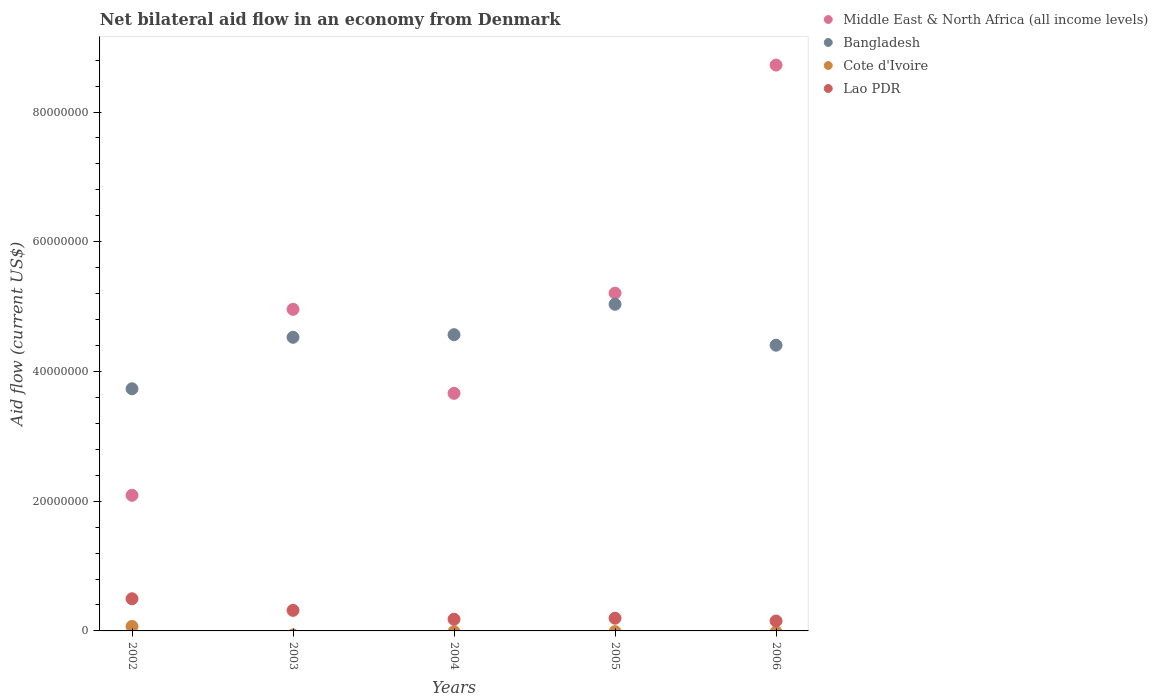How many different coloured dotlines are there?
Give a very brief answer. 4. Is the number of dotlines equal to the number of legend labels?
Offer a very short reply. No. What is the net bilateral aid flow in Middle East & North Africa (all income levels) in 2004?
Your answer should be compact. 3.66e+07. Across all years, what is the maximum net bilateral aid flow in Lao PDR?
Provide a succinct answer. 4.96e+06. Across all years, what is the minimum net bilateral aid flow in Cote d'Ivoire?
Ensure brevity in your answer.  0. In which year was the net bilateral aid flow in Cote d'Ivoire maximum?
Ensure brevity in your answer.  2002. What is the total net bilateral aid flow in Middle East & North Africa (all income levels) in the graph?
Offer a very short reply. 2.46e+08. What is the difference between the net bilateral aid flow in Bangladesh in 2003 and that in 2006?
Keep it short and to the point. 1.22e+06. What is the difference between the net bilateral aid flow in Middle East & North Africa (all income levels) in 2002 and the net bilateral aid flow in Cote d'Ivoire in 2003?
Your answer should be very brief. 2.09e+07. What is the average net bilateral aid flow in Bangladesh per year?
Give a very brief answer. 4.45e+07. In the year 2004, what is the difference between the net bilateral aid flow in Lao PDR and net bilateral aid flow in Middle East & North Africa (all income levels)?
Your response must be concise. -3.48e+07. In how many years, is the net bilateral aid flow in Middle East & North Africa (all income levels) greater than 24000000 US$?
Give a very brief answer. 4. What is the ratio of the net bilateral aid flow in Lao PDR in 2004 to that in 2006?
Give a very brief answer. 1.18. What is the difference between the highest and the second highest net bilateral aid flow in Lao PDR?
Offer a terse response. 1.79e+06. What is the difference between the highest and the lowest net bilateral aid flow in Middle East & North Africa (all income levels)?
Make the answer very short. 6.63e+07. In how many years, is the net bilateral aid flow in Bangladesh greater than the average net bilateral aid flow in Bangladesh taken over all years?
Your answer should be very brief. 3. Is the sum of the net bilateral aid flow in Middle East & North Africa (all income levels) in 2002 and 2004 greater than the maximum net bilateral aid flow in Bangladesh across all years?
Ensure brevity in your answer.  Yes. Is it the case that in every year, the sum of the net bilateral aid flow in Cote d'Ivoire and net bilateral aid flow in Lao PDR  is greater than the net bilateral aid flow in Middle East & North Africa (all income levels)?
Your answer should be compact. No. Is the net bilateral aid flow in Lao PDR strictly greater than the net bilateral aid flow in Middle East & North Africa (all income levels) over the years?
Make the answer very short. No. How many years are there in the graph?
Your response must be concise. 5. Does the graph contain grids?
Your response must be concise. No. How are the legend labels stacked?
Your response must be concise. Vertical. What is the title of the graph?
Provide a succinct answer. Net bilateral aid flow in an economy from Denmark. Does "Mozambique" appear as one of the legend labels in the graph?
Make the answer very short. No. What is the label or title of the Y-axis?
Keep it short and to the point. Aid flow (current US$). What is the Aid flow (current US$) of Middle East & North Africa (all income levels) in 2002?
Ensure brevity in your answer.  2.09e+07. What is the Aid flow (current US$) in Bangladesh in 2002?
Offer a very short reply. 3.73e+07. What is the Aid flow (current US$) of Cote d'Ivoire in 2002?
Give a very brief answer. 6.90e+05. What is the Aid flow (current US$) of Lao PDR in 2002?
Provide a short and direct response. 4.96e+06. What is the Aid flow (current US$) in Middle East & North Africa (all income levels) in 2003?
Your answer should be very brief. 4.96e+07. What is the Aid flow (current US$) in Bangladesh in 2003?
Offer a very short reply. 4.53e+07. What is the Aid flow (current US$) of Cote d'Ivoire in 2003?
Make the answer very short. 0. What is the Aid flow (current US$) of Lao PDR in 2003?
Your answer should be very brief. 3.17e+06. What is the Aid flow (current US$) of Middle East & North Africa (all income levels) in 2004?
Offer a very short reply. 3.66e+07. What is the Aid flow (current US$) of Bangladesh in 2004?
Your response must be concise. 4.57e+07. What is the Aid flow (current US$) in Lao PDR in 2004?
Provide a short and direct response. 1.80e+06. What is the Aid flow (current US$) in Middle East & North Africa (all income levels) in 2005?
Make the answer very short. 5.21e+07. What is the Aid flow (current US$) in Bangladesh in 2005?
Provide a short and direct response. 5.04e+07. What is the Aid flow (current US$) in Cote d'Ivoire in 2005?
Ensure brevity in your answer.  0. What is the Aid flow (current US$) of Lao PDR in 2005?
Offer a very short reply. 1.96e+06. What is the Aid flow (current US$) in Middle East & North Africa (all income levels) in 2006?
Give a very brief answer. 8.72e+07. What is the Aid flow (current US$) in Bangladesh in 2006?
Provide a succinct answer. 4.40e+07. What is the Aid flow (current US$) in Lao PDR in 2006?
Your answer should be compact. 1.53e+06. Across all years, what is the maximum Aid flow (current US$) of Middle East & North Africa (all income levels)?
Provide a short and direct response. 8.72e+07. Across all years, what is the maximum Aid flow (current US$) of Bangladesh?
Your response must be concise. 5.04e+07. Across all years, what is the maximum Aid flow (current US$) in Cote d'Ivoire?
Offer a terse response. 6.90e+05. Across all years, what is the maximum Aid flow (current US$) in Lao PDR?
Your response must be concise. 4.96e+06. Across all years, what is the minimum Aid flow (current US$) in Middle East & North Africa (all income levels)?
Provide a short and direct response. 2.09e+07. Across all years, what is the minimum Aid flow (current US$) in Bangladesh?
Ensure brevity in your answer.  3.73e+07. Across all years, what is the minimum Aid flow (current US$) of Lao PDR?
Ensure brevity in your answer.  1.53e+06. What is the total Aid flow (current US$) in Middle East & North Africa (all income levels) in the graph?
Ensure brevity in your answer.  2.46e+08. What is the total Aid flow (current US$) in Bangladesh in the graph?
Your answer should be compact. 2.23e+08. What is the total Aid flow (current US$) of Cote d'Ivoire in the graph?
Provide a short and direct response. 6.90e+05. What is the total Aid flow (current US$) of Lao PDR in the graph?
Your answer should be very brief. 1.34e+07. What is the difference between the Aid flow (current US$) in Middle East & North Africa (all income levels) in 2002 and that in 2003?
Offer a very short reply. -2.87e+07. What is the difference between the Aid flow (current US$) of Bangladesh in 2002 and that in 2003?
Give a very brief answer. -7.94e+06. What is the difference between the Aid flow (current US$) of Lao PDR in 2002 and that in 2003?
Your response must be concise. 1.79e+06. What is the difference between the Aid flow (current US$) of Middle East & North Africa (all income levels) in 2002 and that in 2004?
Ensure brevity in your answer.  -1.57e+07. What is the difference between the Aid flow (current US$) of Bangladesh in 2002 and that in 2004?
Give a very brief answer. -8.34e+06. What is the difference between the Aid flow (current US$) of Lao PDR in 2002 and that in 2004?
Your answer should be compact. 3.16e+06. What is the difference between the Aid flow (current US$) of Middle East & North Africa (all income levels) in 2002 and that in 2005?
Your answer should be very brief. -3.12e+07. What is the difference between the Aid flow (current US$) of Bangladesh in 2002 and that in 2005?
Give a very brief answer. -1.30e+07. What is the difference between the Aid flow (current US$) in Lao PDR in 2002 and that in 2005?
Keep it short and to the point. 3.00e+06. What is the difference between the Aid flow (current US$) of Middle East & North Africa (all income levels) in 2002 and that in 2006?
Ensure brevity in your answer.  -6.63e+07. What is the difference between the Aid flow (current US$) in Bangladesh in 2002 and that in 2006?
Provide a short and direct response. -6.72e+06. What is the difference between the Aid flow (current US$) of Lao PDR in 2002 and that in 2006?
Your answer should be compact. 3.43e+06. What is the difference between the Aid flow (current US$) of Middle East & North Africa (all income levels) in 2003 and that in 2004?
Provide a short and direct response. 1.30e+07. What is the difference between the Aid flow (current US$) of Bangladesh in 2003 and that in 2004?
Your response must be concise. -4.00e+05. What is the difference between the Aid flow (current US$) in Lao PDR in 2003 and that in 2004?
Ensure brevity in your answer.  1.37e+06. What is the difference between the Aid flow (current US$) in Middle East & North Africa (all income levels) in 2003 and that in 2005?
Give a very brief answer. -2.50e+06. What is the difference between the Aid flow (current US$) of Bangladesh in 2003 and that in 2005?
Ensure brevity in your answer.  -5.09e+06. What is the difference between the Aid flow (current US$) in Lao PDR in 2003 and that in 2005?
Offer a terse response. 1.21e+06. What is the difference between the Aid flow (current US$) in Middle East & North Africa (all income levels) in 2003 and that in 2006?
Offer a very short reply. -3.77e+07. What is the difference between the Aid flow (current US$) in Bangladesh in 2003 and that in 2006?
Keep it short and to the point. 1.22e+06. What is the difference between the Aid flow (current US$) in Lao PDR in 2003 and that in 2006?
Ensure brevity in your answer.  1.64e+06. What is the difference between the Aid flow (current US$) in Middle East & North Africa (all income levels) in 2004 and that in 2005?
Provide a short and direct response. -1.54e+07. What is the difference between the Aid flow (current US$) in Bangladesh in 2004 and that in 2005?
Offer a very short reply. -4.69e+06. What is the difference between the Aid flow (current US$) of Lao PDR in 2004 and that in 2005?
Your response must be concise. -1.60e+05. What is the difference between the Aid flow (current US$) of Middle East & North Africa (all income levels) in 2004 and that in 2006?
Make the answer very short. -5.06e+07. What is the difference between the Aid flow (current US$) in Bangladesh in 2004 and that in 2006?
Offer a very short reply. 1.62e+06. What is the difference between the Aid flow (current US$) of Lao PDR in 2004 and that in 2006?
Ensure brevity in your answer.  2.70e+05. What is the difference between the Aid flow (current US$) in Middle East & North Africa (all income levels) in 2005 and that in 2006?
Provide a short and direct response. -3.52e+07. What is the difference between the Aid flow (current US$) of Bangladesh in 2005 and that in 2006?
Your answer should be compact. 6.31e+06. What is the difference between the Aid flow (current US$) of Middle East & North Africa (all income levels) in 2002 and the Aid flow (current US$) of Bangladesh in 2003?
Offer a very short reply. -2.44e+07. What is the difference between the Aid flow (current US$) in Middle East & North Africa (all income levels) in 2002 and the Aid flow (current US$) in Lao PDR in 2003?
Your response must be concise. 1.77e+07. What is the difference between the Aid flow (current US$) of Bangladesh in 2002 and the Aid flow (current US$) of Lao PDR in 2003?
Provide a succinct answer. 3.42e+07. What is the difference between the Aid flow (current US$) in Cote d'Ivoire in 2002 and the Aid flow (current US$) in Lao PDR in 2003?
Your answer should be very brief. -2.48e+06. What is the difference between the Aid flow (current US$) in Middle East & North Africa (all income levels) in 2002 and the Aid flow (current US$) in Bangladesh in 2004?
Your answer should be very brief. -2.48e+07. What is the difference between the Aid flow (current US$) in Middle East & North Africa (all income levels) in 2002 and the Aid flow (current US$) in Lao PDR in 2004?
Keep it short and to the point. 1.91e+07. What is the difference between the Aid flow (current US$) of Bangladesh in 2002 and the Aid flow (current US$) of Lao PDR in 2004?
Your response must be concise. 3.55e+07. What is the difference between the Aid flow (current US$) of Cote d'Ivoire in 2002 and the Aid flow (current US$) of Lao PDR in 2004?
Provide a short and direct response. -1.11e+06. What is the difference between the Aid flow (current US$) in Middle East & North Africa (all income levels) in 2002 and the Aid flow (current US$) in Bangladesh in 2005?
Ensure brevity in your answer.  -2.94e+07. What is the difference between the Aid flow (current US$) of Middle East & North Africa (all income levels) in 2002 and the Aid flow (current US$) of Lao PDR in 2005?
Give a very brief answer. 1.90e+07. What is the difference between the Aid flow (current US$) of Bangladesh in 2002 and the Aid flow (current US$) of Lao PDR in 2005?
Provide a succinct answer. 3.54e+07. What is the difference between the Aid flow (current US$) in Cote d'Ivoire in 2002 and the Aid flow (current US$) in Lao PDR in 2005?
Give a very brief answer. -1.27e+06. What is the difference between the Aid flow (current US$) of Middle East & North Africa (all income levels) in 2002 and the Aid flow (current US$) of Bangladesh in 2006?
Provide a succinct answer. -2.31e+07. What is the difference between the Aid flow (current US$) of Middle East & North Africa (all income levels) in 2002 and the Aid flow (current US$) of Lao PDR in 2006?
Your response must be concise. 1.94e+07. What is the difference between the Aid flow (current US$) of Bangladesh in 2002 and the Aid flow (current US$) of Lao PDR in 2006?
Your response must be concise. 3.58e+07. What is the difference between the Aid flow (current US$) in Cote d'Ivoire in 2002 and the Aid flow (current US$) in Lao PDR in 2006?
Offer a very short reply. -8.40e+05. What is the difference between the Aid flow (current US$) of Middle East & North Africa (all income levels) in 2003 and the Aid flow (current US$) of Bangladesh in 2004?
Your response must be concise. 3.91e+06. What is the difference between the Aid flow (current US$) of Middle East & North Africa (all income levels) in 2003 and the Aid flow (current US$) of Lao PDR in 2004?
Offer a terse response. 4.78e+07. What is the difference between the Aid flow (current US$) in Bangladesh in 2003 and the Aid flow (current US$) in Lao PDR in 2004?
Your answer should be compact. 4.35e+07. What is the difference between the Aid flow (current US$) in Middle East & North Africa (all income levels) in 2003 and the Aid flow (current US$) in Bangladesh in 2005?
Offer a very short reply. -7.80e+05. What is the difference between the Aid flow (current US$) of Middle East & North Africa (all income levels) in 2003 and the Aid flow (current US$) of Lao PDR in 2005?
Make the answer very short. 4.76e+07. What is the difference between the Aid flow (current US$) of Bangladesh in 2003 and the Aid flow (current US$) of Lao PDR in 2005?
Offer a terse response. 4.33e+07. What is the difference between the Aid flow (current US$) of Middle East & North Africa (all income levels) in 2003 and the Aid flow (current US$) of Bangladesh in 2006?
Provide a succinct answer. 5.53e+06. What is the difference between the Aid flow (current US$) of Middle East & North Africa (all income levels) in 2003 and the Aid flow (current US$) of Lao PDR in 2006?
Offer a terse response. 4.80e+07. What is the difference between the Aid flow (current US$) of Bangladesh in 2003 and the Aid flow (current US$) of Lao PDR in 2006?
Offer a terse response. 4.37e+07. What is the difference between the Aid flow (current US$) in Middle East & North Africa (all income levels) in 2004 and the Aid flow (current US$) in Bangladesh in 2005?
Offer a very short reply. -1.37e+07. What is the difference between the Aid flow (current US$) of Middle East & North Africa (all income levels) in 2004 and the Aid flow (current US$) of Lao PDR in 2005?
Your answer should be compact. 3.47e+07. What is the difference between the Aid flow (current US$) in Bangladesh in 2004 and the Aid flow (current US$) in Lao PDR in 2005?
Your answer should be very brief. 4.37e+07. What is the difference between the Aid flow (current US$) of Middle East & North Africa (all income levels) in 2004 and the Aid flow (current US$) of Bangladesh in 2006?
Offer a terse response. -7.42e+06. What is the difference between the Aid flow (current US$) in Middle East & North Africa (all income levels) in 2004 and the Aid flow (current US$) in Lao PDR in 2006?
Keep it short and to the point. 3.51e+07. What is the difference between the Aid flow (current US$) of Bangladesh in 2004 and the Aid flow (current US$) of Lao PDR in 2006?
Offer a very short reply. 4.41e+07. What is the difference between the Aid flow (current US$) in Middle East & North Africa (all income levels) in 2005 and the Aid flow (current US$) in Bangladesh in 2006?
Ensure brevity in your answer.  8.03e+06. What is the difference between the Aid flow (current US$) of Middle East & North Africa (all income levels) in 2005 and the Aid flow (current US$) of Lao PDR in 2006?
Offer a very short reply. 5.06e+07. What is the difference between the Aid flow (current US$) in Bangladesh in 2005 and the Aid flow (current US$) in Lao PDR in 2006?
Provide a short and direct response. 4.88e+07. What is the average Aid flow (current US$) of Middle East & North Africa (all income levels) per year?
Offer a terse response. 4.93e+07. What is the average Aid flow (current US$) of Bangladesh per year?
Your response must be concise. 4.45e+07. What is the average Aid flow (current US$) in Cote d'Ivoire per year?
Provide a succinct answer. 1.38e+05. What is the average Aid flow (current US$) in Lao PDR per year?
Your answer should be compact. 2.68e+06. In the year 2002, what is the difference between the Aid flow (current US$) of Middle East & North Africa (all income levels) and Aid flow (current US$) of Bangladesh?
Give a very brief answer. -1.64e+07. In the year 2002, what is the difference between the Aid flow (current US$) of Middle East & North Africa (all income levels) and Aid flow (current US$) of Cote d'Ivoire?
Make the answer very short. 2.02e+07. In the year 2002, what is the difference between the Aid flow (current US$) in Middle East & North Africa (all income levels) and Aid flow (current US$) in Lao PDR?
Your answer should be very brief. 1.60e+07. In the year 2002, what is the difference between the Aid flow (current US$) in Bangladesh and Aid flow (current US$) in Cote d'Ivoire?
Offer a terse response. 3.66e+07. In the year 2002, what is the difference between the Aid flow (current US$) in Bangladesh and Aid flow (current US$) in Lao PDR?
Provide a succinct answer. 3.24e+07. In the year 2002, what is the difference between the Aid flow (current US$) of Cote d'Ivoire and Aid flow (current US$) of Lao PDR?
Your answer should be very brief. -4.27e+06. In the year 2003, what is the difference between the Aid flow (current US$) in Middle East & North Africa (all income levels) and Aid flow (current US$) in Bangladesh?
Make the answer very short. 4.31e+06. In the year 2003, what is the difference between the Aid flow (current US$) of Middle East & North Africa (all income levels) and Aid flow (current US$) of Lao PDR?
Ensure brevity in your answer.  4.64e+07. In the year 2003, what is the difference between the Aid flow (current US$) in Bangladesh and Aid flow (current US$) in Lao PDR?
Your answer should be compact. 4.21e+07. In the year 2004, what is the difference between the Aid flow (current US$) in Middle East & North Africa (all income levels) and Aid flow (current US$) in Bangladesh?
Ensure brevity in your answer.  -9.04e+06. In the year 2004, what is the difference between the Aid flow (current US$) in Middle East & North Africa (all income levels) and Aid flow (current US$) in Lao PDR?
Your answer should be compact. 3.48e+07. In the year 2004, what is the difference between the Aid flow (current US$) in Bangladesh and Aid flow (current US$) in Lao PDR?
Offer a terse response. 4.39e+07. In the year 2005, what is the difference between the Aid flow (current US$) of Middle East & North Africa (all income levels) and Aid flow (current US$) of Bangladesh?
Your answer should be very brief. 1.72e+06. In the year 2005, what is the difference between the Aid flow (current US$) of Middle East & North Africa (all income levels) and Aid flow (current US$) of Lao PDR?
Offer a terse response. 5.01e+07. In the year 2005, what is the difference between the Aid flow (current US$) in Bangladesh and Aid flow (current US$) in Lao PDR?
Provide a short and direct response. 4.84e+07. In the year 2006, what is the difference between the Aid flow (current US$) of Middle East & North Africa (all income levels) and Aid flow (current US$) of Bangladesh?
Offer a terse response. 4.32e+07. In the year 2006, what is the difference between the Aid flow (current US$) of Middle East & North Africa (all income levels) and Aid flow (current US$) of Lao PDR?
Give a very brief answer. 8.57e+07. In the year 2006, what is the difference between the Aid flow (current US$) of Bangladesh and Aid flow (current US$) of Lao PDR?
Make the answer very short. 4.25e+07. What is the ratio of the Aid flow (current US$) of Middle East & North Africa (all income levels) in 2002 to that in 2003?
Give a very brief answer. 0.42. What is the ratio of the Aid flow (current US$) in Bangladesh in 2002 to that in 2003?
Your response must be concise. 0.82. What is the ratio of the Aid flow (current US$) of Lao PDR in 2002 to that in 2003?
Provide a succinct answer. 1.56. What is the ratio of the Aid flow (current US$) of Middle East & North Africa (all income levels) in 2002 to that in 2004?
Keep it short and to the point. 0.57. What is the ratio of the Aid flow (current US$) of Bangladesh in 2002 to that in 2004?
Offer a very short reply. 0.82. What is the ratio of the Aid flow (current US$) in Lao PDR in 2002 to that in 2004?
Offer a very short reply. 2.76. What is the ratio of the Aid flow (current US$) in Middle East & North Africa (all income levels) in 2002 to that in 2005?
Make the answer very short. 0.4. What is the ratio of the Aid flow (current US$) of Bangladesh in 2002 to that in 2005?
Your answer should be compact. 0.74. What is the ratio of the Aid flow (current US$) in Lao PDR in 2002 to that in 2005?
Offer a very short reply. 2.53. What is the ratio of the Aid flow (current US$) of Middle East & North Africa (all income levels) in 2002 to that in 2006?
Your response must be concise. 0.24. What is the ratio of the Aid flow (current US$) of Bangladesh in 2002 to that in 2006?
Your response must be concise. 0.85. What is the ratio of the Aid flow (current US$) of Lao PDR in 2002 to that in 2006?
Keep it short and to the point. 3.24. What is the ratio of the Aid flow (current US$) in Middle East & North Africa (all income levels) in 2003 to that in 2004?
Offer a very short reply. 1.35. What is the ratio of the Aid flow (current US$) in Lao PDR in 2003 to that in 2004?
Keep it short and to the point. 1.76. What is the ratio of the Aid flow (current US$) of Middle East & North Africa (all income levels) in 2003 to that in 2005?
Provide a succinct answer. 0.95. What is the ratio of the Aid flow (current US$) of Bangladesh in 2003 to that in 2005?
Ensure brevity in your answer.  0.9. What is the ratio of the Aid flow (current US$) of Lao PDR in 2003 to that in 2005?
Make the answer very short. 1.62. What is the ratio of the Aid flow (current US$) in Middle East & North Africa (all income levels) in 2003 to that in 2006?
Provide a short and direct response. 0.57. What is the ratio of the Aid flow (current US$) of Bangladesh in 2003 to that in 2006?
Give a very brief answer. 1.03. What is the ratio of the Aid flow (current US$) in Lao PDR in 2003 to that in 2006?
Provide a short and direct response. 2.07. What is the ratio of the Aid flow (current US$) in Middle East & North Africa (all income levels) in 2004 to that in 2005?
Make the answer very short. 0.7. What is the ratio of the Aid flow (current US$) of Bangladesh in 2004 to that in 2005?
Offer a terse response. 0.91. What is the ratio of the Aid flow (current US$) of Lao PDR in 2004 to that in 2005?
Make the answer very short. 0.92. What is the ratio of the Aid flow (current US$) of Middle East & North Africa (all income levels) in 2004 to that in 2006?
Make the answer very short. 0.42. What is the ratio of the Aid flow (current US$) of Bangladesh in 2004 to that in 2006?
Your response must be concise. 1.04. What is the ratio of the Aid flow (current US$) of Lao PDR in 2004 to that in 2006?
Your response must be concise. 1.18. What is the ratio of the Aid flow (current US$) in Middle East & North Africa (all income levels) in 2005 to that in 2006?
Offer a terse response. 0.6. What is the ratio of the Aid flow (current US$) of Bangladesh in 2005 to that in 2006?
Provide a succinct answer. 1.14. What is the ratio of the Aid flow (current US$) in Lao PDR in 2005 to that in 2006?
Provide a succinct answer. 1.28. What is the difference between the highest and the second highest Aid flow (current US$) in Middle East & North Africa (all income levels)?
Ensure brevity in your answer.  3.52e+07. What is the difference between the highest and the second highest Aid flow (current US$) of Bangladesh?
Offer a very short reply. 4.69e+06. What is the difference between the highest and the second highest Aid flow (current US$) of Lao PDR?
Your answer should be compact. 1.79e+06. What is the difference between the highest and the lowest Aid flow (current US$) of Middle East & North Africa (all income levels)?
Your answer should be compact. 6.63e+07. What is the difference between the highest and the lowest Aid flow (current US$) in Bangladesh?
Your answer should be compact. 1.30e+07. What is the difference between the highest and the lowest Aid flow (current US$) of Cote d'Ivoire?
Offer a terse response. 6.90e+05. What is the difference between the highest and the lowest Aid flow (current US$) of Lao PDR?
Provide a succinct answer. 3.43e+06. 